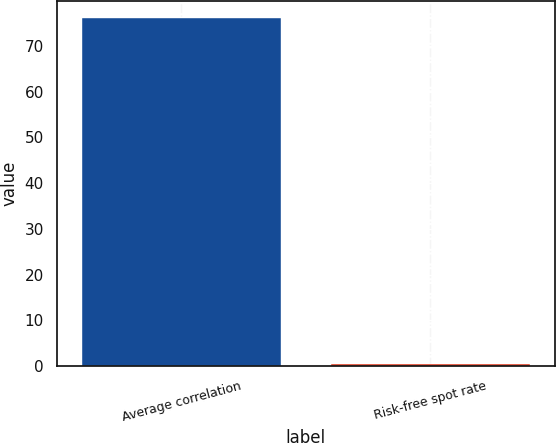Convert chart. <chart><loc_0><loc_0><loc_500><loc_500><bar_chart><fcel>Average correlation<fcel>Risk-free spot rate<nl><fcel>76<fcel>0.4<nl></chart> 